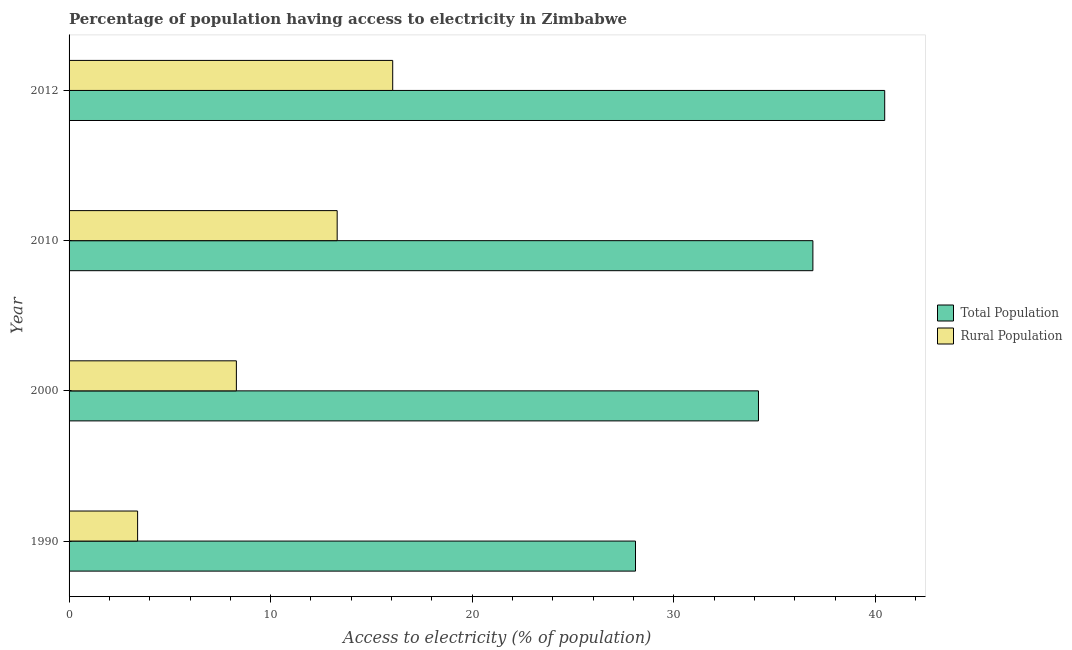How many bars are there on the 1st tick from the top?
Provide a succinct answer. 2. What is the label of the 1st group of bars from the top?
Your answer should be very brief. 2012. In how many cases, is the number of bars for a given year not equal to the number of legend labels?
Provide a succinct answer. 0. What is the percentage of rural population having access to electricity in 2012?
Make the answer very short. 16.05. Across all years, what is the maximum percentage of population having access to electricity?
Keep it short and to the point. 40.46. Across all years, what is the minimum percentage of population having access to electricity?
Your answer should be very brief. 28.1. In which year was the percentage of population having access to electricity minimum?
Ensure brevity in your answer.  1990. What is the total percentage of rural population having access to electricity in the graph?
Provide a succinct answer. 41.05. What is the difference between the percentage of population having access to electricity in 2000 and that in 2012?
Offer a terse response. -6.26. What is the difference between the percentage of rural population having access to electricity in 2000 and the percentage of population having access to electricity in 2012?
Offer a terse response. -32.16. What is the average percentage of rural population having access to electricity per year?
Your answer should be very brief. 10.26. In the year 2012, what is the difference between the percentage of rural population having access to electricity and percentage of population having access to electricity?
Ensure brevity in your answer.  -24.41. What is the ratio of the percentage of rural population having access to electricity in 2000 to that in 2012?
Your answer should be very brief. 0.52. Is the percentage of population having access to electricity in 2010 less than that in 2012?
Provide a short and direct response. Yes. Is the difference between the percentage of population having access to electricity in 2000 and 2012 greater than the difference between the percentage of rural population having access to electricity in 2000 and 2012?
Offer a very short reply. Yes. What is the difference between the highest and the second highest percentage of population having access to electricity?
Your response must be concise. 3.56. What is the difference between the highest and the lowest percentage of population having access to electricity?
Keep it short and to the point. 12.36. What does the 1st bar from the top in 2010 represents?
Provide a succinct answer. Rural Population. What does the 1st bar from the bottom in 1990 represents?
Your answer should be very brief. Total Population. How many bars are there?
Give a very brief answer. 8. Are all the bars in the graph horizontal?
Provide a succinct answer. Yes. How many years are there in the graph?
Provide a short and direct response. 4. What is the difference between two consecutive major ticks on the X-axis?
Offer a terse response. 10. Are the values on the major ticks of X-axis written in scientific E-notation?
Your response must be concise. No. Does the graph contain grids?
Provide a short and direct response. No. How many legend labels are there?
Ensure brevity in your answer.  2. How are the legend labels stacked?
Offer a very short reply. Vertical. What is the title of the graph?
Offer a terse response. Percentage of population having access to electricity in Zimbabwe. Does "Quality of trade" appear as one of the legend labels in the graph?
Provide a short and direct response. No. What is the label or title of the X-axis?
Keep it short and to the point. Access to electricity (% of population). What is the label or title of the Y-axis?
Offer a very short reply. Year. What is the Access to electricity (% of population) in Total Population in 1990?
Provide a succinct answer. 28.1. What is the Access to electricity (% of population) of Total Population in 2000?
Give a very brief answer. 34.2. What is the Access to electricity (% of population) in Rural Population in 2000?
Your response must be concise. 8.3. What is the Access to electricity (% of population) in Total Population in 2010?
Give a very brief answer. 36.9. What is the Access to electricity (% of population) of Rural Population in 2010?
Offer a terse response. 13.3. What is the Access to electricity (% of population) in Total Population in 2012?
Offer a very short reply. 40.46. What is the Access to electricity (% of population) in Rural Population in 2012?
Keep it short and to the point. 16.05. Across all years, what is the maximum Access to electricity (% of population) in Total Population?
Ensure brevity in your answer.  40.46. Across all years, what is the maximum Access to electricity (% of population) in Rural Population?
Give a very brief answer. 16.05. Across all years, what is the minimum Access to electricity (% of population) of Total Population?
Ensure brevity in your answer.  28.1. Across all years, what is the minimum Access to electricity (% of population) of Rural Population?
Your answer should be compact. 3.4. What is the total Access to electricity (% of population) in Total Population in the graph?
Your answer should be compact. 139.66. What is the total Access to electricity (% of population) of Rural Population in the graph?
Keep it short and to the point. 41.05. What is the difference between the Access to electricity (% of population) in Rural Population in 1990 and that in 2010?
Your answer should be compact. -9.9. What is the difference between the Access to electricity (% of population) of Total Population in 1990 and that in 2012?
Provide a short and direct response. -12.36. What is the difference between the Access to electricity (% of population) of Rural Population in 1990 and that in 2012?
Make the answer very short. -12.65. What is the difference between the Access to electricity (% of population) of Rural Population in 2000 and that in 2010?
Provide a short and direct response. -5. What is the difference between the Access to electricity (% of population) of Total Population in 2000 and that in 2012?
Provide a succinct answer. -6.26. What is the difference between the Access to electricity (% of population) of Rural Population in 2000 and that in 2012?
Your answer should be compact. -7.75. What is the difference between the Access to electricity (% of population) in Total Population in 2010 and that in 2012?
Ensure brevity in your answer.  -3.56. What is the difference between the Access to electricity (% of population) of Rural Population in 2010 and that in 2012?
Ensure brevity in your answer.  -2.75. What is the difference between the Access to electricity (% of population) of Total Population in 1990 and the Access to electricity (% of population) of Rural Population in 2000?
Keep it short and to the point. 19.8. What is the difference between the Access to electricity (% of population) of Total Population in 1990 and the Access to electricity (% of population) of Rural Population in 2012?
Your response must be concise. 12.05. What is the difference between the Access to electricity (% of population) in Total Population in 2000 and the Access to electricity (% of population) in Rural Population in 2010?
Ensure brevity in your answer.  20.9. What is the difference between the Access to electricity (% of population) of Total Population in 2000 and the Access to electricity (% of population) of Rural Population in 2012?
Make the answer very short. 18.15. What is the difference between the Access to electricity (% of population) in Total Population in 2010 and the Access to electricity (% of population) in Rural Population in 2012?
Provide a succinct answer. 20.85. What is the average Access to electricity (% of population) of Total Population per year?
Give a very brief answer. 34.92. What is the average Access to electricity (% of population) in Rural Population per year?
Offer a very short reply. 10.26. In the year 1990, what is the difference between the Access to electricity (% of population) of Total Population and Access to electricity (% of population) of Rural Population?
Your answer should be very brief. 24.7. In the year 2000, what is the difference between the Access to electricity (% of population) in Total Population and Access to electricity (% of population) in Rural Population?
Provide a succinct answer. 25.9. In the year 2010, what is the difference between the Access to electricity (% of population) in Total Population and Access to electricity (% of population) in Rural Population?
Your answer should be compact. 23.6. In the year 2012, what is the difference between the Access to electricity (% of population) in Total Population and Access to electricity (% of population) in Rural Population?
Ensure brevity in your answer.  24.41. What is the ratio of the Access to electricity (% of population) of Total Population in 1990 to that in 2000?
Your response must be concise. 0.82. What is the ratio of the Access to electricity (% of population) of Rural Population in 1990 to that in 2000?
Your answer should be compact. 0.41. What is the ratio of the Access to electricity (% of population) of Total Population in 1990 to that in 2010?
Give a very brief answer. 0.76. What is the ratio of the Access to electricity (% of population) in Rural Population in 1990 to that in 2010?
Provide a short and direct response. 0.26. What is the ratio of the Access to electricity (% of population) in Total Population in 1990 to that in 2012?
Ensure brevity in your answer.  0.69. What is the ratio of the Access to electricity (% of population) in Rural Population in 1990 to that in 2012?
Your answer should be very brief. 0.21. What is the ratio of the Access to electricity (% of population) of Total Population in 2000 to that in 2010?
Offer a very short reply. 0.93. What is the ratio of the Access to electricity (% of population) in Rural Population in 2000 to that in 2010?
Ensure brevity in your answer.  0.62. What is the ratio of the Access to electricity (% of population) in Total Population in 2000 to that in 2012?
Offer a terse response. 0.85. What is the ratio of the Access to electricity (% of population) of Rural Population in 2000 to that in 2012?
Your answer should be compact. 0.52. What is the ratio of the Access to electricity (% of population) of Total Population in 2010 to that in 2012?
Ensure brevity in your answer.  0.91. What is the ratio of the Access to electricity (% of population) of Rural Population in 2010 to that in 2012?
Keep it short and to the point. 0.83. What is the difference between the highest and the second highest Access to electricity (% of population) of Total Population?
Your response must be concise. 3.56. What is the difference between the highest and the second highest Access to electricity (% of population) in Rural Population?
Your answer should be very brief. 2.75. What is the difference between the highest and the lowest Access to electricity (% of population) of Total Population?
Your answer should be very brief. 12.36. What is the difference between the highest and the lowest Access to electricity (% of population) of Rural Population?
Offer a very short reply. 12.65. 